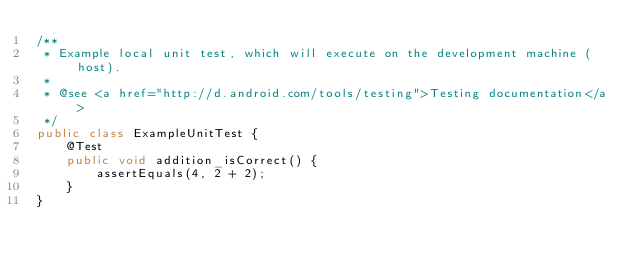<code> <loc_0><loc_0><loc_500><loc_500><_Java_>/**
 * Example local unit test, which will execute on the development machine (host).
 *
 * @see <a href="http://d.android.com/tools/testing">Testing documentation</a>
 */
public class ExampleUnitTest {
    @Test
    public void addition_isCorrect() {
        assertEquals(4, 2 + 2);
    }
}</code> 